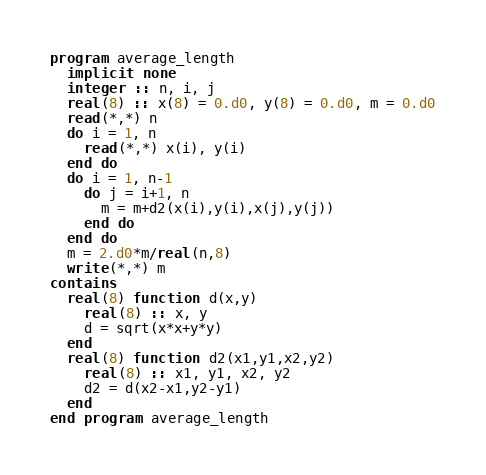<code> <loc_0><loc_0><loc_500><loc_500><_FORTRAN_>program average_length
  implicit none
  integer :: n, i, j
  real(8) :: x(8) = 0.d0, y(8) = 0.d0, m = 0.d0
  read(*,*) n
  do i = 1, n
    read(*,*) x(i), y(i)
  end do
  do i = 1, n-1
    do j = i+1, n
      m = m+d2(x(i),y(i),x(j),y(j))
    end do
  end do
  m = 2.d0*m/real(n,8)
  write(*,*) m
contains
  real(8) function d(x,y)
    real(8) :: x, y
    d = sqrt(x*x+y*y)
  end
  real(8) function d2(x1,y1,x2,y2)
    real(8) :: x1, y1, x2, y2
    d2 = d(x2-x1,y2-y1)
  end
end program average_length</code> 